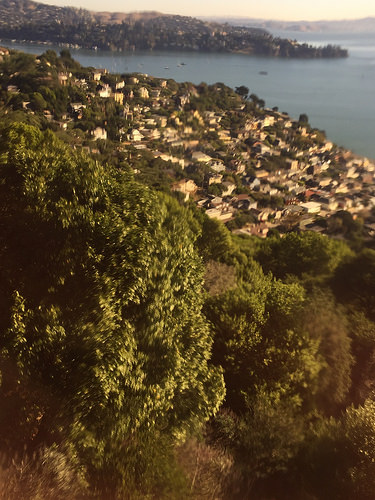<image>
Can you confirm if the sea is in the town? No. The sea is not contained within the town. These objects have a different spatial relationship. 